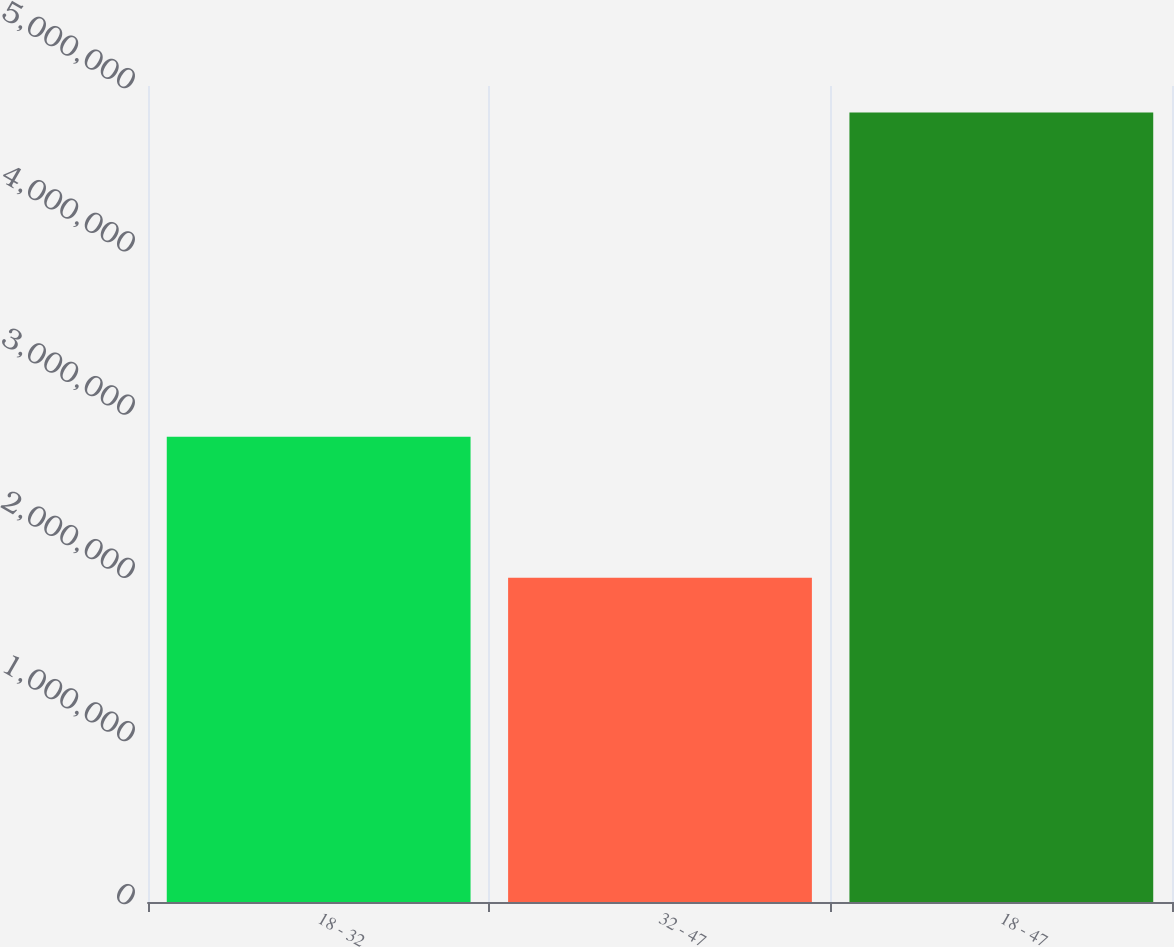<chart> <loc_0><loc_0><loc_500><loc_500><bar_chart><fcel>18 - 32<fcel>32 - 47<fcel>18 - 47<nl><fcel>2.85058e+06<fcel>1.98694e+06<fcel>4.83751e+06<nl></chart> 